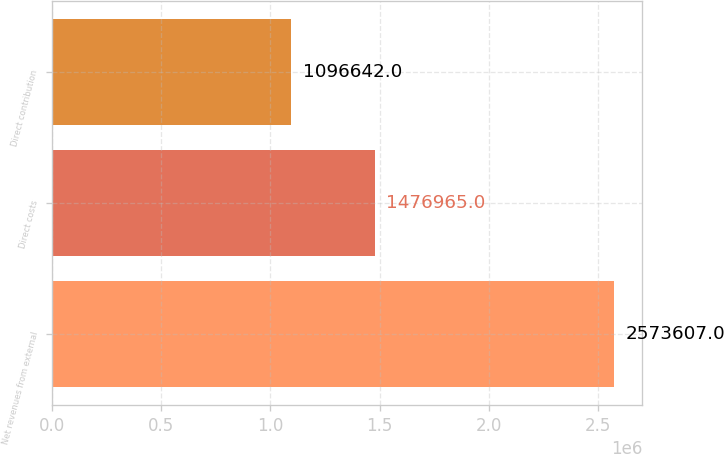<chart> <loc_0><loc_0><loc_500><loc_500><bar_chart><fcel>Net revenues from external<fcel>Direct costs<fcel>Direct contribution<nl><fcel>2.57361e+06<fcel>1.47696e+06<fcel>1.09664e+06<nl></chart> 